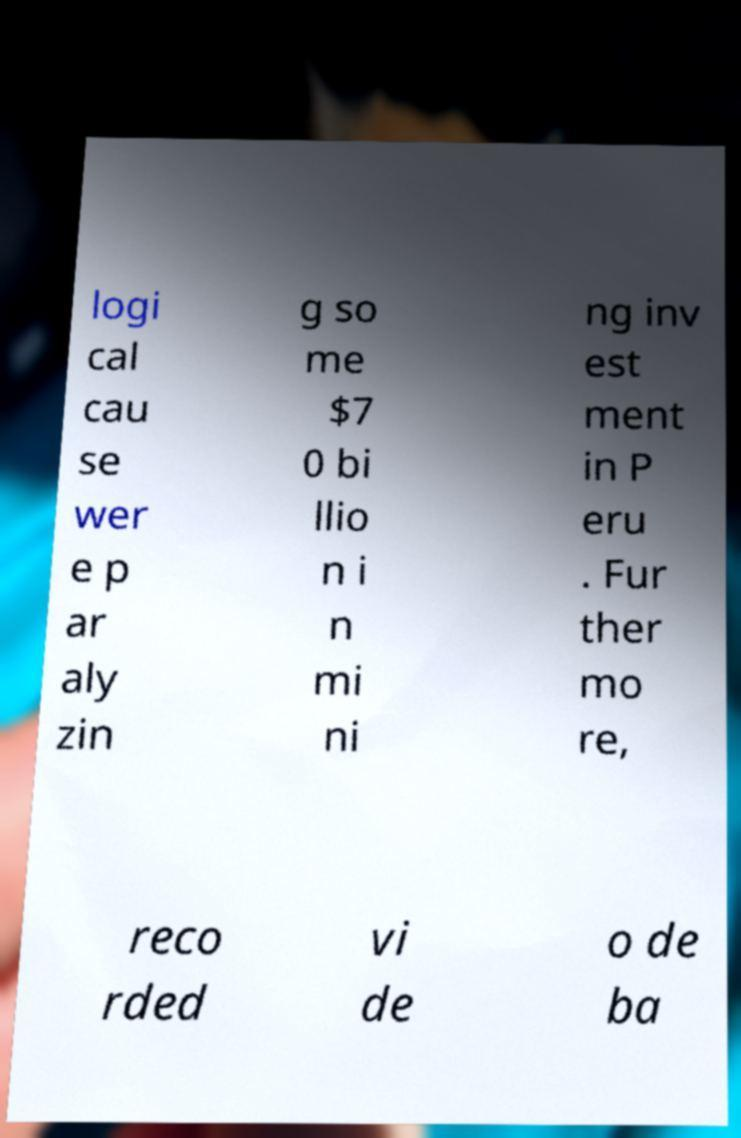Can you accurately transcribe the text from the provided image for me? logi cal cau se wer e p ar aly zin g so me $7 0 bi llio n i n mi ni ng inv est ment in P eru . Fur ther mo re, reco rded vi de o de ba 